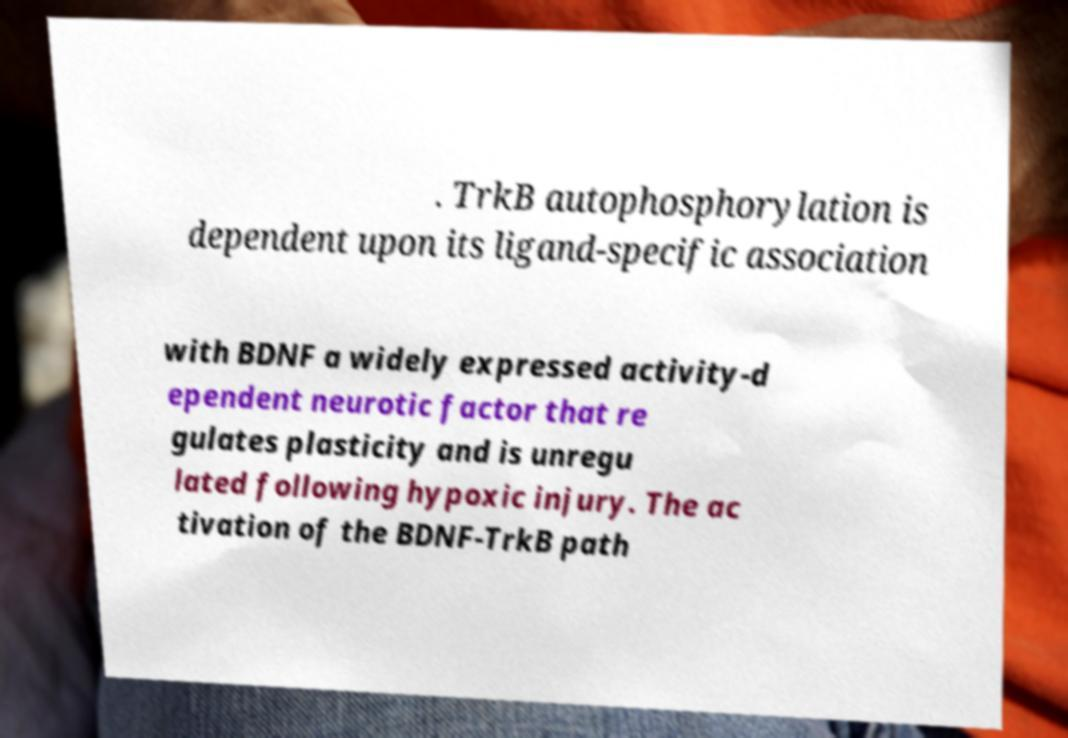I need the written content from this picture converted into text. Can you do that? . TrkB autophosphorylation is dependent upon its ligand-specific association with BDNF a widely expressed activity-d ependent neurotic factor that re gulates plasticity and is unregu lated following hypoxic injury. The ac tivation of the BDNF-TrkB path 